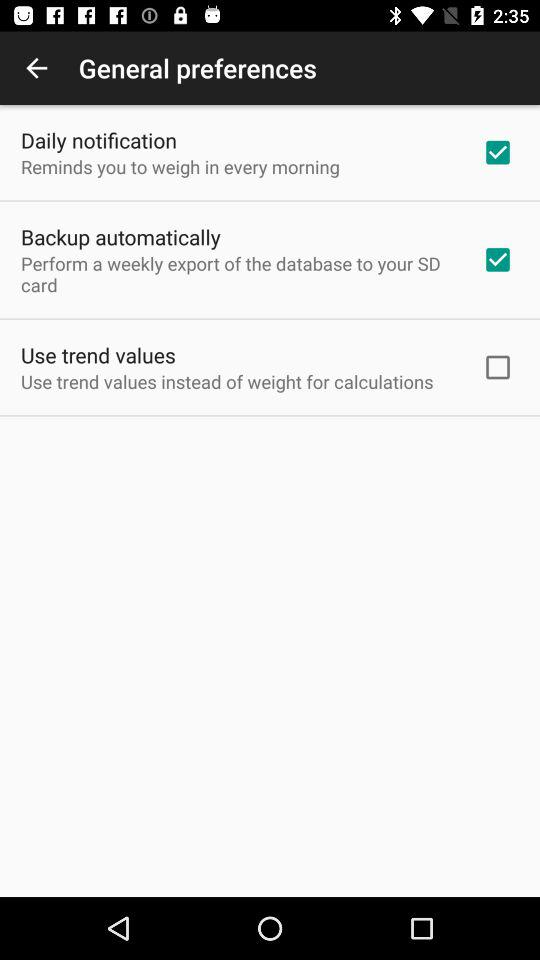Which general preferences are checked? The checked general preferences are "Daily notification" and "Backup automatically". 